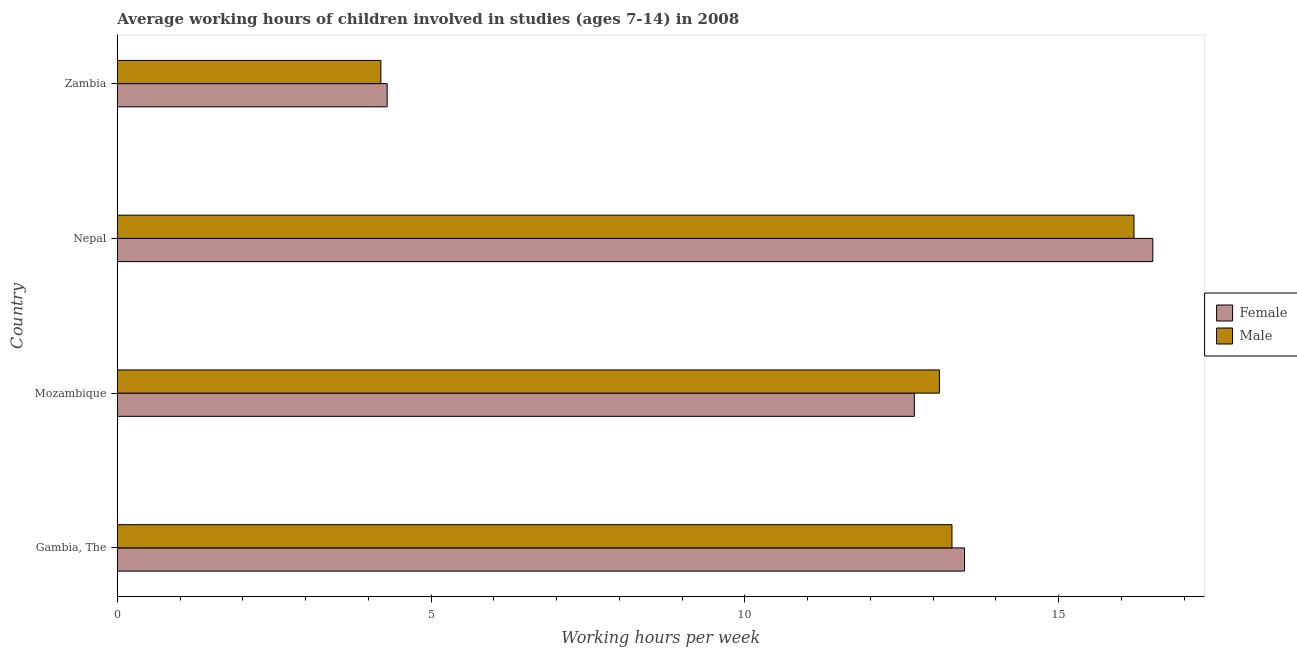How many different coloured bars are there?
Give a very brief answer. 2. Are the number of bars per tick equal to the number of legend labels?
Offer a very short reply. Yes. Are the number of bars on each tick of the Y-axis equal?
Give a very brief answer. Yes. How many bars are there on the 2nd tick from the bottom?
Ensure brevity in your answer.  2. What is the label of the 2nd group of bars from the top?
Offer a terse response. Nepal. In how many cases, is the number of bars for a given country not equal to the number of legend labels?
Offer a terse response. 0. Across all countries, what is the minimum average working hour of male children?
Provide a short and direct response. 4.2. In which country was the average working hour of female children maximum?
Offer a very short reply. Nepal. In which country was the average working hour of female children minimum?
Make the answer very short. Zambia. What is the total average working hour of female children in the graph?
Your answer should be very brief. 47. What is the difference between the average working hour of female children in Gambia, The and that in Nepal?
Your answer should be compact. -3. What is the difference between the average working hour of male children in Mozambique and the average working hour of female children in Nepal?
Make the answer very short. -3.4. What is the difference between the average working hour of male children and average working hour of female children in Mozambique?
Provide a succinct answer. 0.4. In how many countries, is the average working hour of female children greater than 9 hours?
Provide a short and direct response. 3. What is the ratio of the average working hour of female children in Gambia, The to that in Mozambique?
Provide a succinct answer. 1.06. Is the average working hour of female children in Mozambique less than that in Nepal?
Offer a very short reply. Yes. What is the difference between the highest and the lowest average working hour of female children?
Offer a very short reply. 12.2. Is the sum of the average working hour of female children in Mozambique and Nepal greater than the maximum average working hour of male children across all countries?
Provide a succinct answer. Yes. What does the 2nd bar from the bottom in Mozambique represents?
Ensure brevity in your answer.  Male. How many countries are there in the graph?
Your answer should be very brief. 4. What is the difference between two consecutive major ticks on the X-axis?
Your answer should be compact. 5. Does the graph contain any zero values?
Give a very brief answer. No. Where does the legend appear in the graph?
Give a very brief answer. Center right. How many legend labels are there?
Provide a short and direct response. 2. What is the title of the graph?
Offer a very short reply. Average working hours of children involved in studies (ages 7-14) in 2008. What is the label or title of the X-axis?
Provide a succinct answer. Working hours per week. What is the label or title of the Y-axis?
Your response must be concise. Country. What is the Working hours per week of Female in Gambia, The?
Your answer should be compact. 13.5. What is the Working hours per week of Male in Gambia, The?
Give a very brief answer. 13.3. What is the Working hours per week in Female in Mozambique?
Your answer should be compact. 12.7. What is the Working hours per week of Male in Mozambique?
Keep it short and to the point. 13.1. What is the Working hours per week in Male in Nepal?
Provide a succinct answer. 16.2. What is the Working hours per week in Female in Zambia?
Offer a terse response. 4.3. What is the Working hours per week of Male in Zambia?
Your response must be concise. 4.2. Across all countries, what is the minimum Working hours per week of Male?
Give a very brief answer. 4.2. What is the total Working hours per week in Male in the graph?
Your answer should be compact. 46.8. What is the difference between the Working hours per week of Male in Gambia, The and that in Nepal?
Provide a succinct answer. -2.9. What is the difference between the Working hours per week in Male in Gambia, The and that in Zambia?
Your answer should be very brief. 9.1. What is the difference between the Working hours per week of Female in Mozambique and that in Nepal?
Offer a terse response. -3.8. What is the difference between the Working hours per week of Male in Mozambique and that in Nepal?
Ensure brevity in your answer.  -3.1. What is the difference between the Working hours per week of Female in Mozambique and that in Zambia?
Provide a short and direct response. 8.4. What is the difference between the Working hours per week of Female in Nepal and that in Zambia?
Keep it short and to the point. 12.2. What is the difference between the Working hours per week of Female in Gambia, The and the Working hours per week of Male in Mozambique?
Offer a very short reply. 0.4. What is the difference between the Working hours per week in Female in Mozambique and the Working hours per week in Male in Nepal?
Keep it short and to the point. -3.5. What is the difference between the Working hours per week of Female in Nepal and the Working hours per week of Male in Zambia?
Offer a very short reply. 12.3. What is the average Working hours per week of Female per country?
Make the answer very short. 11.75. What is the average Working hours per week in Male per country?
Provide a succinct answer. 11.7. What is the difference between the Working hours per week in Female and Working hours per week in Male in Gambia, The?
Make the answer very short. 0.2. What is the difference between the Working hours per week in Female and Working hours per week in Male in Mozambique?
Provide a succinct answer. -0.4. What is the ratio of the Working hours per week in Female in Gambia, The to that in Mozambique?
Provide a short and direct response. 1.06. What is the ratio of the Working hours per week of Male in Gambia, The to that in Mozambique?
Provide a short and direct response. 1.02. What is the ratio of the Working hours per week in Female in Gambia, The to that in Nepal?
Ensure brevity in your answer.  0.82. What is the ratio of the Working hours per week in Male in Gambia, The to that in Nepal?
Ensure brevity in your answer.  0.82. What is the ratio of the Working hours per week of Female in Gambia, The to that in Zambia?
Make the answer very short. 3.14. What is the ratio of the Working hours per week of Male in Gambia, The to that in Zambia?
Provide a succinct answer. 3.17. What is the ratio of the Working hours per week of Female in Mozambique to that in Nepal?
Ensure brevity in your answer.  0.77. What is the ratio of the Working hours per week of Male in Mozambique to that in Nepal?
Ensure brevity in your answer.  0.81. What is the ratio of the Working hours per week in Female in Mozambique to that in Zambia?
Your answer should be very brief. 2.95. What is the ratio of the Working hours per week of Male in Mozambique to that in Zambia?
Offer a terse response. 3.12. What is the ratio of the Working hours per week of Female in Nepal to that in Zambia?
Keep it short and to the point. 3.84. What is the ratio of the Working hours per week of Male in Nepal to that in Zambia?
Make the answer very short. 3.86. What is the difference between the highest and the second highest Working hours per week of Female?
Make the answer very short. 3. What is the difference between the highest and the second highest Working hours per week in Male?
Offer a very short reply. 2.9. What is the difference between the highest and the lowest Working hours per week of Male?
Your answer should be very brief. 12. 